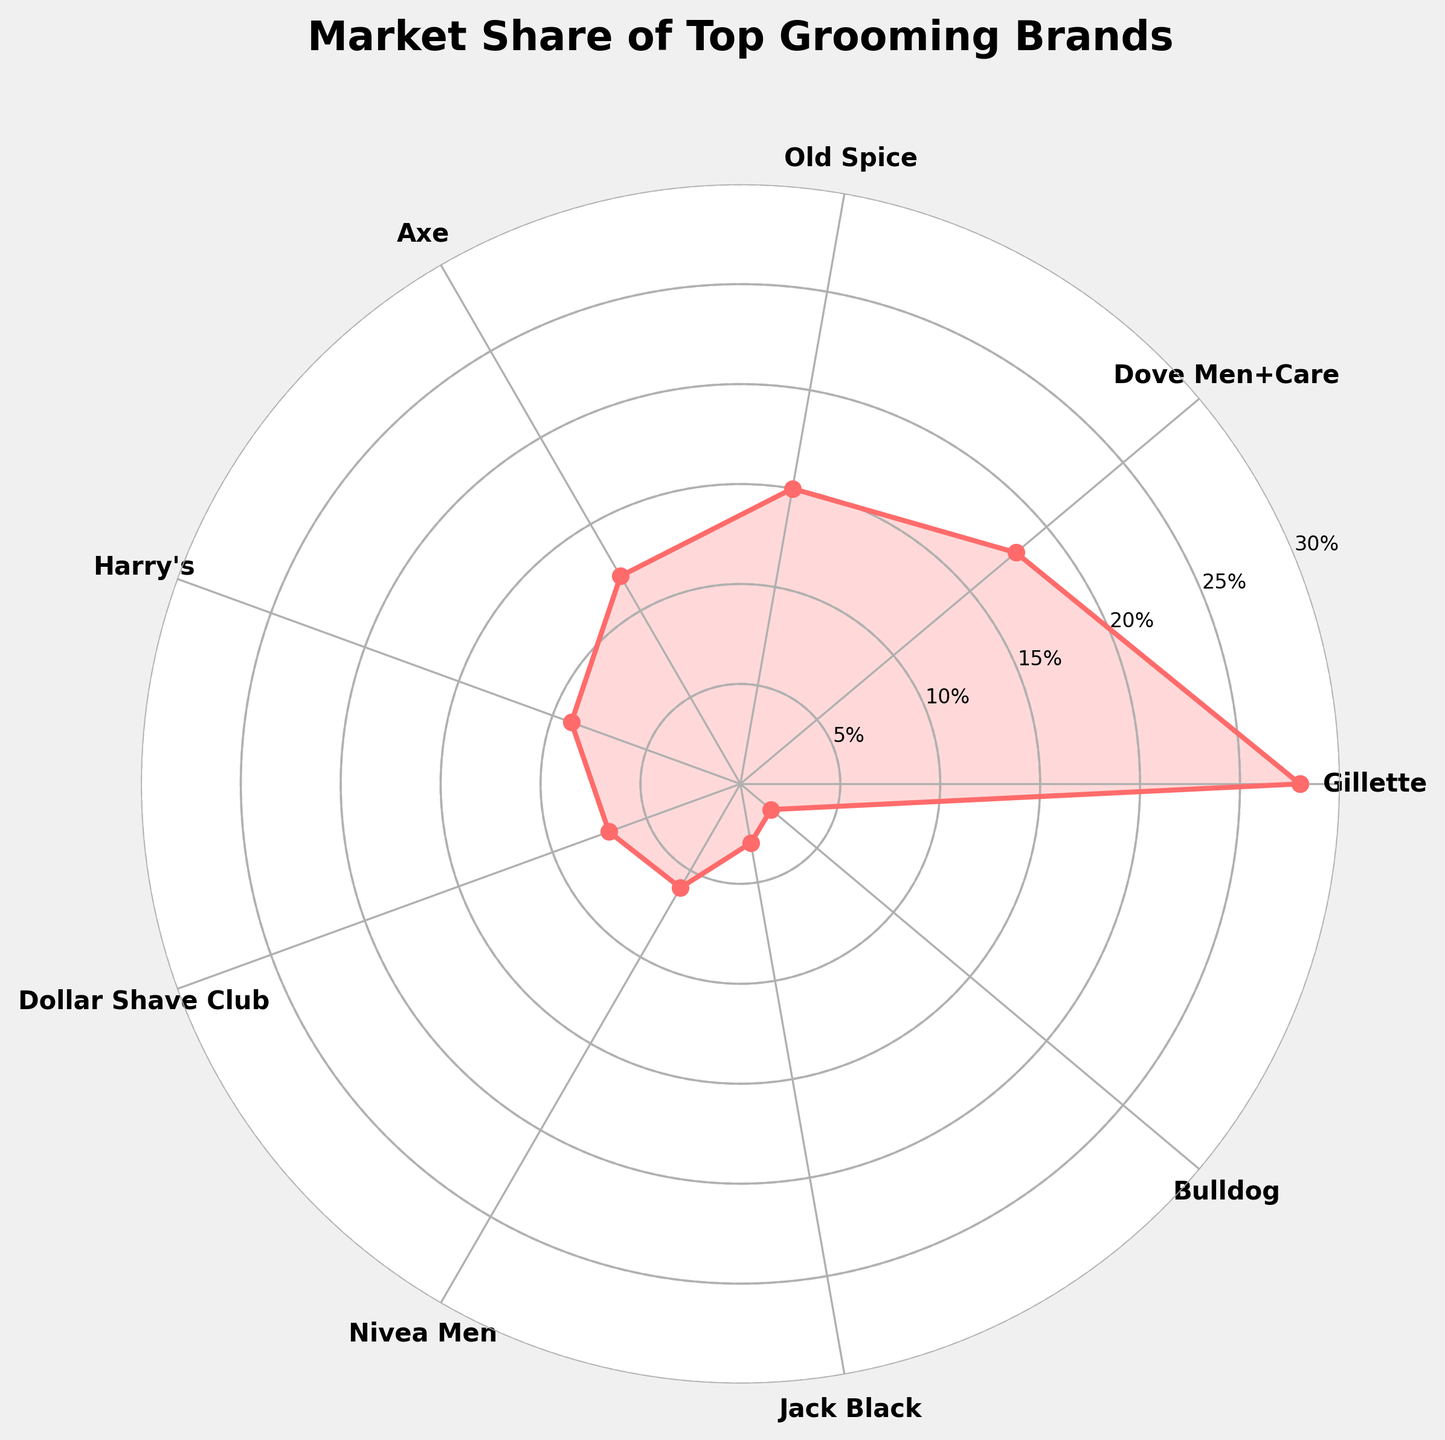What's the title of the figure? The title is located at the top of the figure, and it states the main subject of the chart. In this case, it reads "Market Share of Top Grooming Brands."
Answer: Market Share of Top Grooming Brands What brand has the highest market share and what is its percentage? By looking at the segments of the chart, we can see that the brand with the highest market share is Gillette, which occupies the largest portion at 28%.
Answer: Gillette, 28% Which two brands have the smallest market share, and what are their percentages? Observing the segments with the smallest portions, we see that Bulldog and Jack Black have the smallest market shares, with 2% and 3%, respectively.
Answer: Bulldog, 2% and Jack Black, 3% What is the total market share percentage of Dove Men+Care, Old Spice, and Axe combined? By identifying each brand's segment and adding their percentages, we find: Dove Men+Care (18%) + Old Spice (15%) + Axe (12%) = 45%.
Answer: 45% How does Harry's market share compare to Dollar Shave Club's? From the chart, it shows that Harry's has a market share of 9% whereas Dollar Shave Club has 7%. Therefore, Harry's market share is higher by 2%.
Answer: Higher by 2% What is the average market share of the top three brands? The top three brands in terms of market share are Gillette (28%), Dove Men+Care (18%), and Old Spice (15%). Adding these up gives 28% + 18% + 15% = 61%. Dividing by 3 to get the average: 61% / 3 = 20.33%.
Answer: 20.33% How many brands have a market share greater than or equal to 10%? By visually inspecting the gauge chart, we see that Gillette, Dove Men+Care, Old Spice, and Axe all have market shares greater than or equal to 10%. That makes 4 brands.
Answer: 4 brands What's the market share difference between Gillette and Axe? From the chart, Gillette has 28% and Axe has 12%. Subtracting these, we get 28% - 12% = 16%.
Answer: 16% Which brand has a market share closest to 10%? Observing the chart, the brand with a market share closest to 10% is Harry's, which has a share of 9%.
Answer: Harry's, 9% What is the combined market share of Old Spice, Harry's, and Nivea Men? Adding the percentages of Old Spice (15%), Harry's (9%), and Nivea Men (6%), we get 15% + 9% + 6% = 30%.
Answer: 30% 